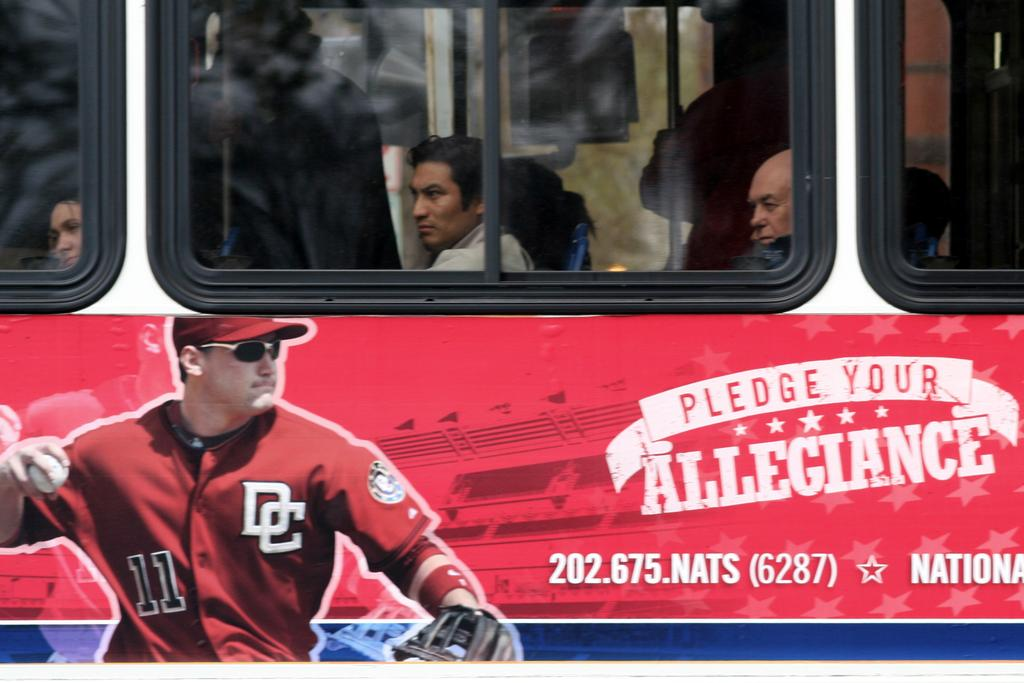<image>
Describe the image concisely. The side of a bus that is advertsing the baseball team from D.C. 